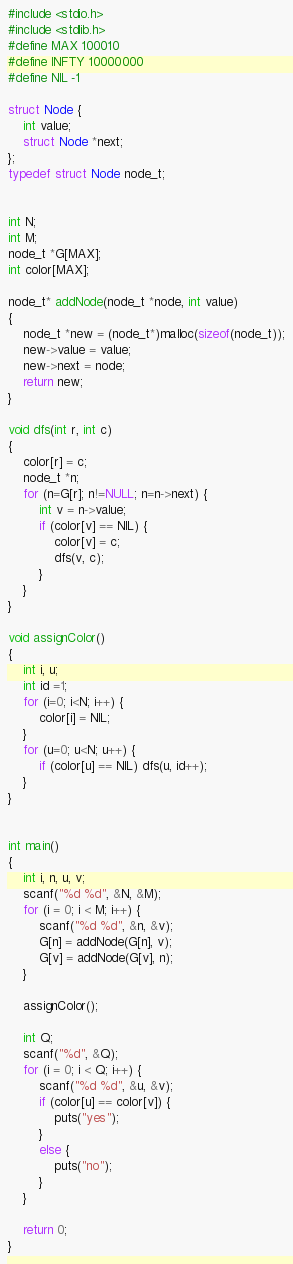<code> <loc_0><loc_0><loc_500><loc_500><_C_>#include <stdio.h>
#include <stdlib.h>
#define MAX 100010
#define INFTY 10000000
#define NIL -1

struct Node {
	int value;
	struct Node *next;
};
typedef struct Node node_t;


int N;
int M;
node_t *G[MAX];
int color[MAX];

node_t* addNode(node_t *node, int value)
{
	node_t *new = (node_t*)malloc(sizeof(node_t));
	new->value = value;
	new->next = node;
	return new;
}

void dfs(int r, int c)
{
	color[r] = c;
	node_t *n;
	for (n=G[r]; n!=NULL; n=n->next) {
		int v = n->value;
		if (color[v] == NIL) {
			color[v] = c;
			dfs(v, c);
		}
	}
}

void assignColor()
{
	int i, u;
	int id =1;
	for (i=0; i<N; i++) {
		color[i] = NIL;
	}
	for (u=0; u<N; u++) {
		if (color[u] == NIL) dfs(u, id++);
	}
}


int main()
{
	int i, n, u, v;	
	scanf("%d %d", &N, &M);	
	for (i = 0; i < M; i++) {
		scanf("%d %d", &n, &v);
		G[n] = addNode(G[n], v);
		G[v] = addNode(G[v], n);
	}
	
	assignColor();
	
	int Q;
	scanf("%d", &Q);
	for (i = 0; i < Q; i++) {
		scanf("%d %d", &u, &v);
		if (color[u] == color[v]) {
			puts("yes");			
		}
		else {
			puts("no");
		}
	}

	return 0;
}</code> 